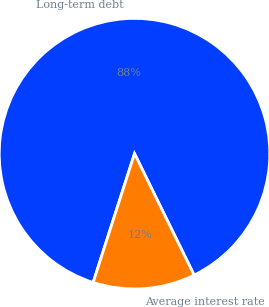Convert chart. <chart><loc_0><loc_0><loc_500><loc_500><pie_chart><fcel>Long-term debt<fcel>Average interest rate<nl><fcel>87.79%<fcel>12.21%<nl></chart> 